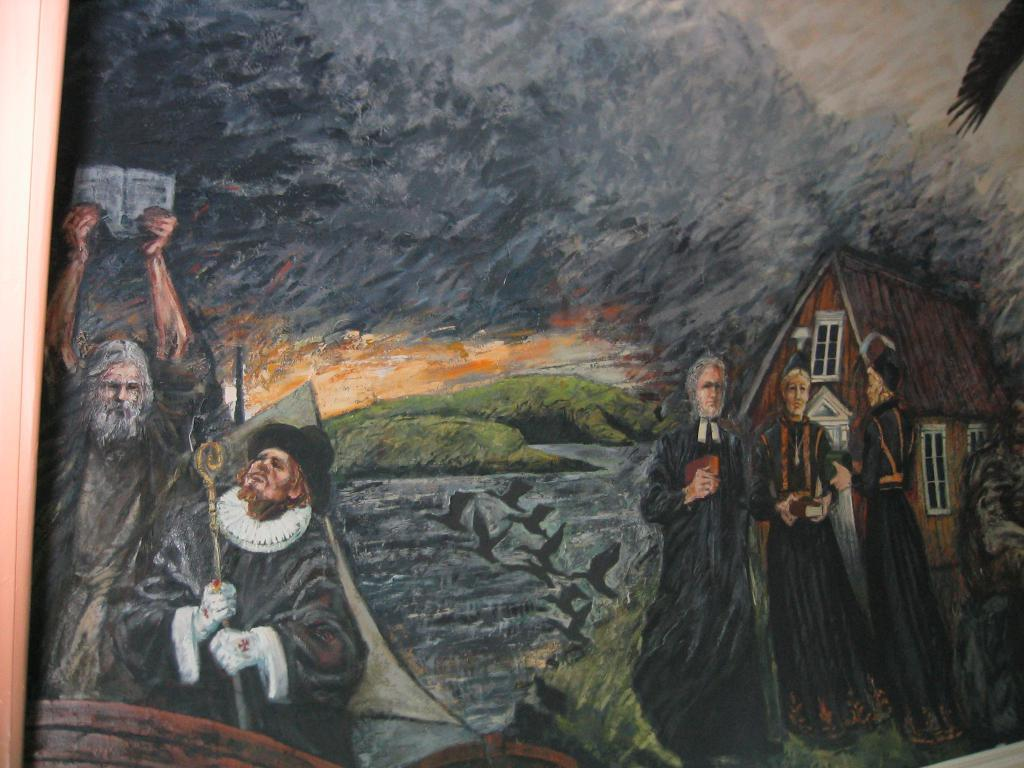What is the main subject of the image? There is a painting in the center of the image. What can be seen in the painting? The painting contains persons and a house. What type of stick is being used by the persons in the painting? There is no stick present in the painting; it only depicts persons and a house. 